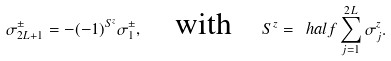Convert formula to latex. <formula><loc_0><loc_0><loc_500><loc_500>\sigma _ { 2 L + 1 } ^ { \pm } = - ( - 1 ) ^ { S ^ { z } } \sigma _ { 1 } ^ { \pm } , \quad \text {with} \quad S ^ { z } = \ h a l f \sum _ { j = 1 } ^ { 2 L } \sigma _ { j } ^ { z } .</formula> 